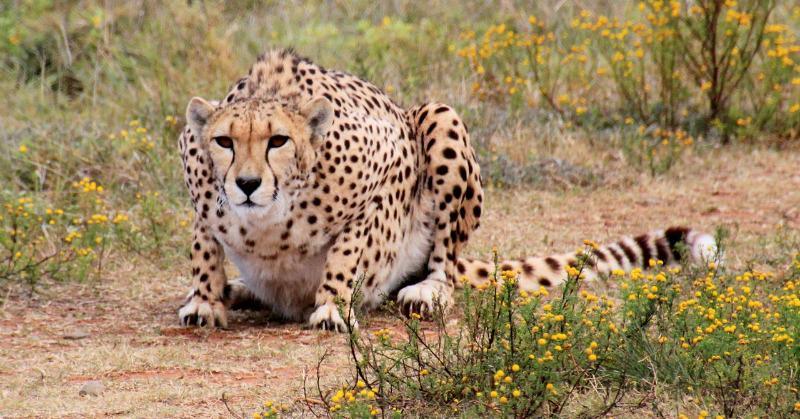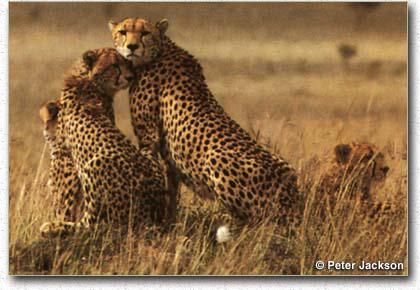The first image is the image on the left, the second image is the image on the right. For the images displayed, is the sentence "One image contains exactly one cheetah, which faces the camera, and the other image contains cheetahs with overlapping bodies." factually correct? Answer yes or no. Yes. The first image is the image on the left, the second image is the image on the right. For the images shown, is this caption "In at least one image there is a single leopard whose facing is left forward." true? Answer yes or no. Yes. 